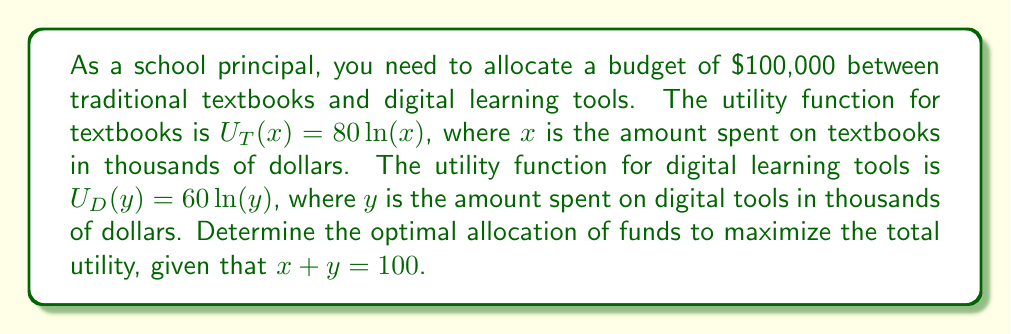Solve this math problem. To solve this problem, we'll use the method of Lagrange multipliers to maximize the total utility function subject to the budget constraint.

1) The total utility function is:
   $U(x,y) = U_T(x) + U_D(y) = 80\ln(x) + 60\ln(y)$

2) The constraint is:
   $g(x,y) = x + y - 100 = 0$

3) Form the Lagrangian function:
   $L(x,y,\lambda) = 80\ln(x) + 60\ln(y) - \lambda(x + y - 100)$

4) Take partial derivatives and set them to zero:
   $\frac{\partial L}{\partial x} = \frac{80}{x} - \lambda = 0$
   $\frac{\partial L}{\partial y} = \frac{60}{y} - \lambda = 0$
   $\frac{\partial L}{\partial \lambda} = x + y - 100 = 0$

5) From the first two equations:
   $\frac{80}{x} = \frac{60}{y}$

6) Cross-multiply:
   $80y = 60x$
   $y = \frac{3}{4}x$

7) Substitute into the constraint equation:
   $x + \frac{3}{4}x = 100$
   $\frac{7}{4}x = 100$
   $x = \frac{400}{7} \approx 57.14$

8) Solve for y:
   $y = 100 - x = 100 - \frac{400}{7} = \frac{300}{7} \approx 42.86$

Therefore, the optimal allocation is approximately $57,140 for textbooks and $42,860 for digital learning tools.
Answer: Optimal allocation: $57,140 for textbooks, $42,860 for digital learning tools. 